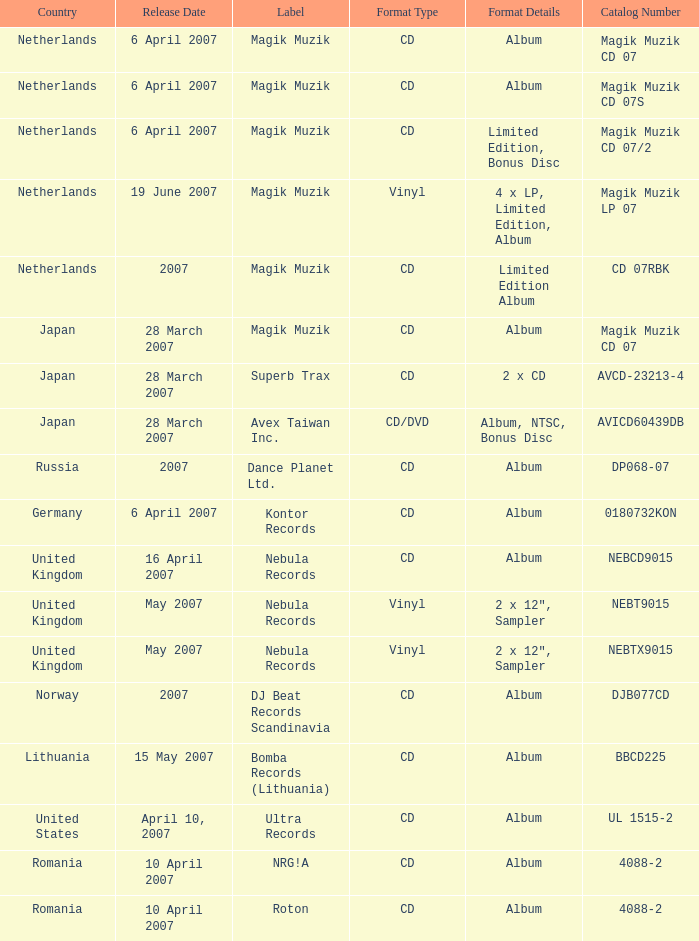Which label released the catalog Magik Muzik CD 07 on 28 March 2007? Magik Muzik. 